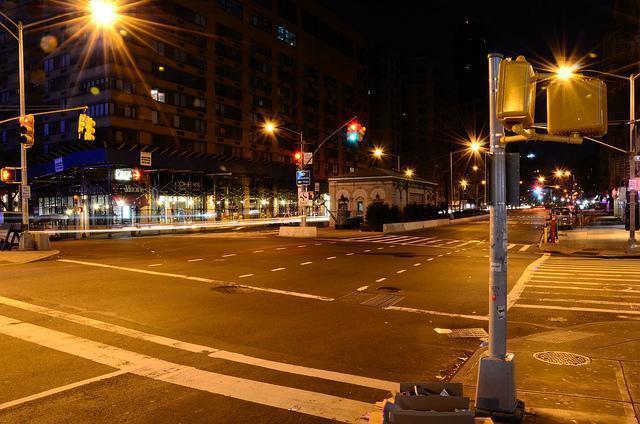How is the street staying illuminated?
Select the accurate answer and provide explanation: 'Answer: answer
Rationale: rationale.'
Options: Fire, sun, street lights, flashlights. Answer: street lights.
Rationale: It is night time, so the sun is not out. there are no flashlights or fires. 